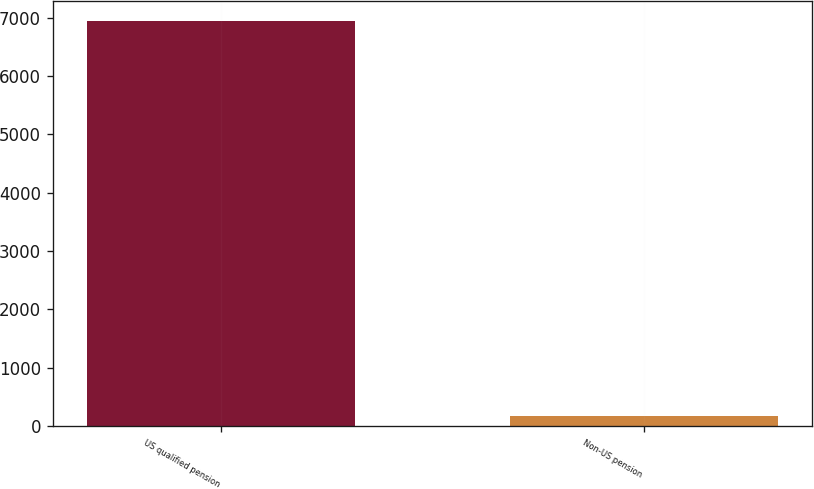Convert chart. <chart><loc_0><loc_0><loc_500><loc_500><bar_chart><fcel>US qualified pension<fcel>Non-US pension<nl><fcel>6944<fcel>173<nl></chart> 